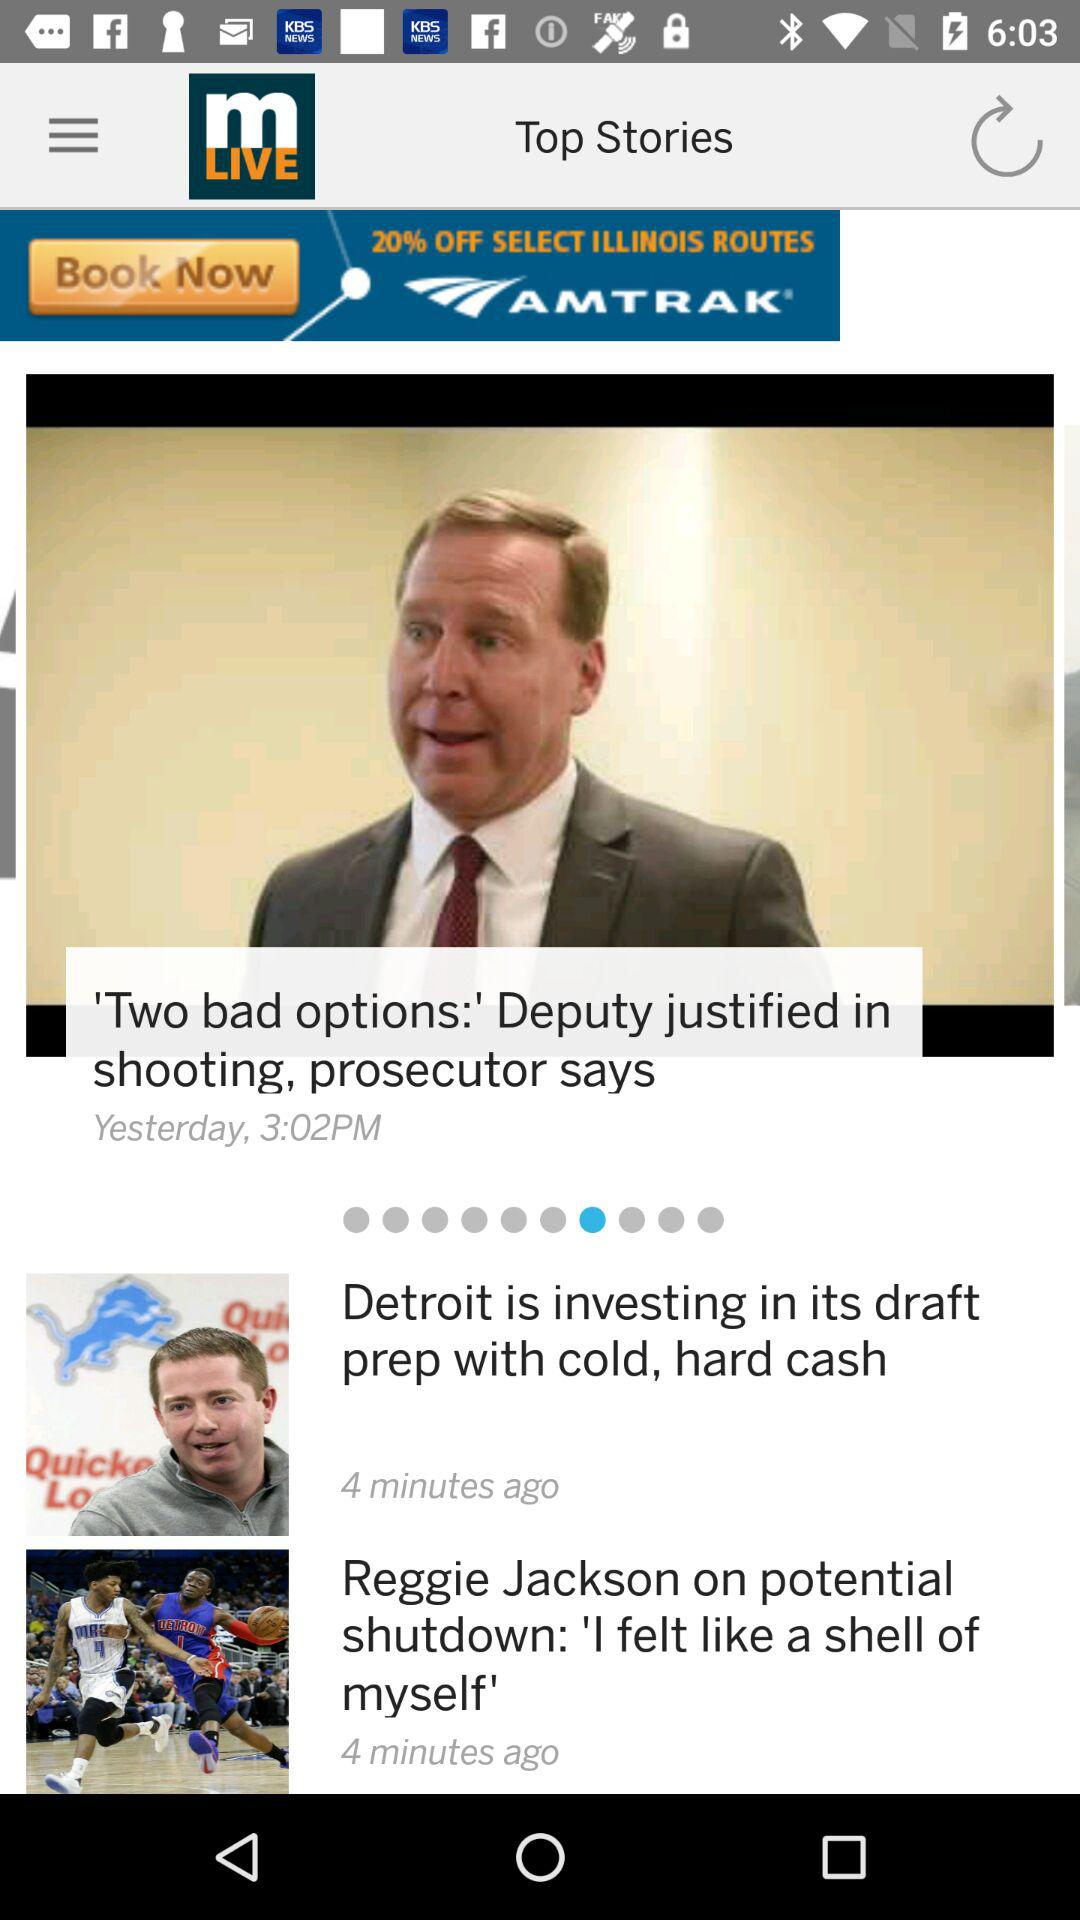When was the story "'Two bad options:'" published? The story "'Two bad options:'" was published yesterday at 3:02 PM. 